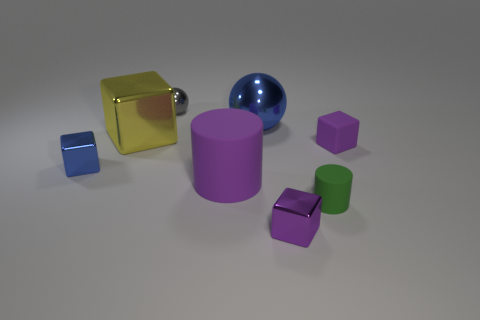Subtract all gray cubes. Subtract all red cylinders. How many cubes are left? 4 Add 1 purple metallic cubes. How many objects exist? 9 Subtract all spheres. How many objects are left? 6 Add 3 large matte blocks. How many large matte blocks exist? 3 Subtract 1 purple cylinders. How many objects are left? 7 Subtract all tiny green matte cylinders. Subtract all large shiny cubes. How many objects are left? 6 Add 4 tiny purple things. How many tiny purple things are left? 6 